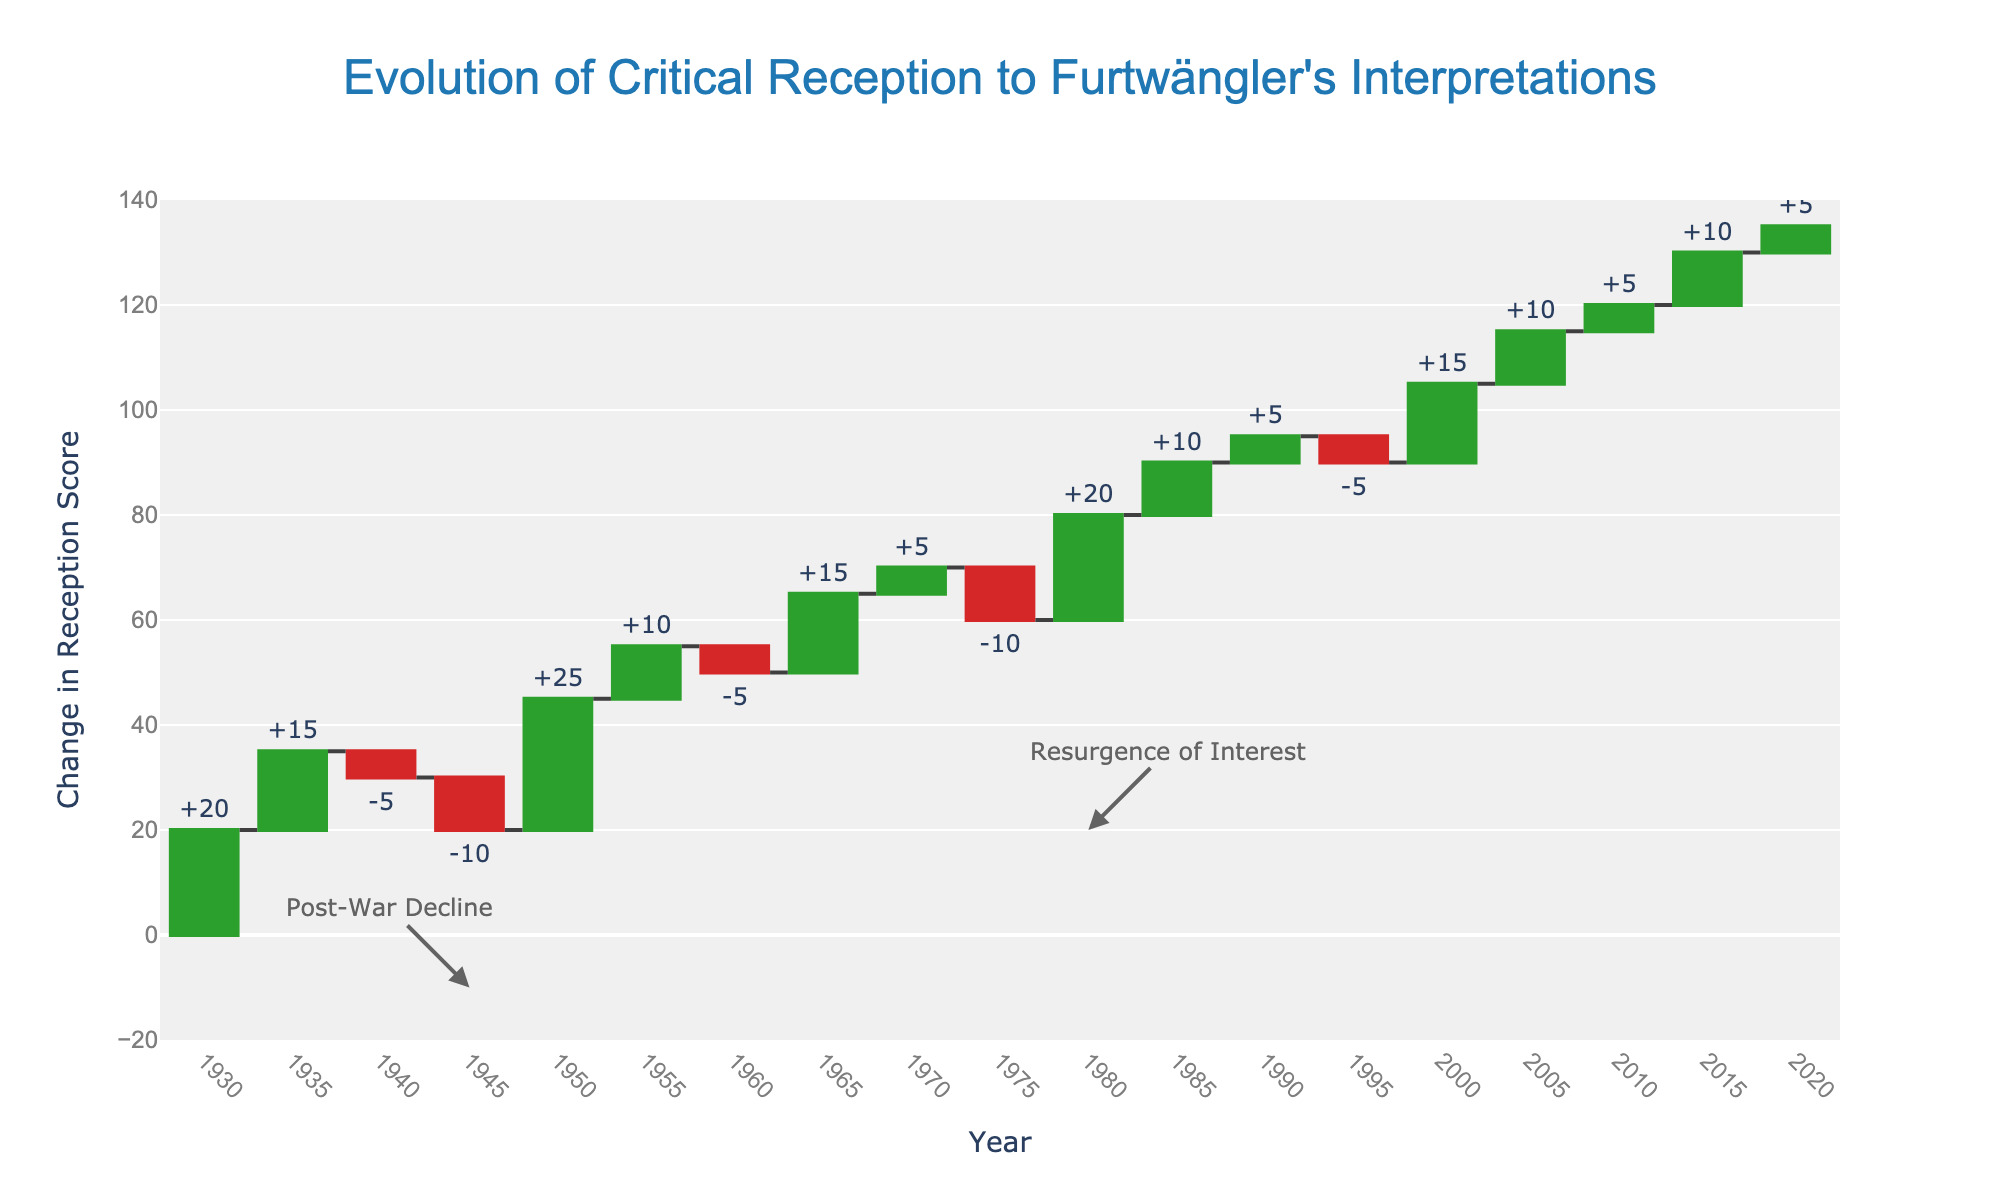what is the overall trend in the reception score over time? Looking at the overall trend from 1930 to 2020, the critical reception of Furtwängler's interpretations generally increased, with notable periods of both growth and decline. The final score in 2020 is higher than the initial score in 1930.
Answer: Increasing trend During which period did Furtwängler's reception see the biggest increase? The period from 1950 to 1955 saw the biggest increase in reception score, with a jump of 25 points from 20 to 45.
Answer: 1950 to 1955 What event is annotated in 1945 and how did it affect Furtwängler's reception? The annotated event in 1945 indicates a "Post-War Decline" in reception, where the score dropped by 10 points from 30 to 20.
Answer: Post-War Decline, -10 points How many times did the reception score decline, and in which years? Reception score declined four times, specifically in 1940 (-5), 1945 (-10), 1960 (-5), and 1975 (-10).
Answer: Four times: 1940, 1945, 1960, 1975 What is the final total reception score in 2020? The final total reception score in 2020 is 135, which is the cumulative result of all the changes over the period.
Answer: 135 Compare the changes in reception score between 1950 and 1980. Which period saw a greater increase? From 1950 to 1955, the score increased by 25 points. From 1980 to 1985, the score increased by 10 points. Therefore, 1950 to 1955 saw a greater increase.
Answer: 1950 to 1955 What is the net change in the reception score from 1970 to 1980? The reception score increased by 10 points in 1970 but dropped by 10 points in 1975, resulting in no net change from 1970 to 1980.
Answer: No net change What can be inferred about the critical reception of Furtwängler's interpretations post-2000 compared to pre-2000? Post-2000, there was consistent and steady growth in the reception score, indicating a resurgence and growing appreciation, while pre-2000 had more variability, with significant drops and increases.
Answer: Steady growth post-2000 How did the event annotated in 1980 influence the reception score? The annotation in 1980, labeled "Resurgence of Interest," corresponds with a 20-point increase in reception score, indicating a renewed appreciation for Furtwängler's work.
Answer: +20 points 